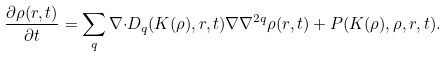<formula> <loc_0><loc_0><loc_500><loc_500>\frac { \partial \rho ( { r } , t ) } { \partial t } = \sum _ { q } \nabla { \cdot } D _ { q } ( K ( \rho ) , { r } , t ) \nabla \nabla ^ { 2 q } \rho ( { r } , t ) + P ( K ( \rho ) , \rho , { r } , t ) .</formula> 